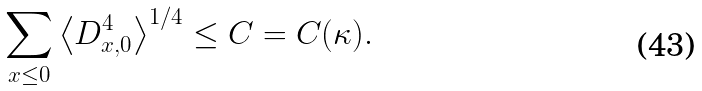<formula> <loc_0><loc_0><loc_500><loc_500>\sum _ { x \leq 0 } \left \langle D ^ { 4 } _ { x , 0 } \right \rangle ^ { 1 / 4 } \leq C = C ( \kappa ) .</formula> 